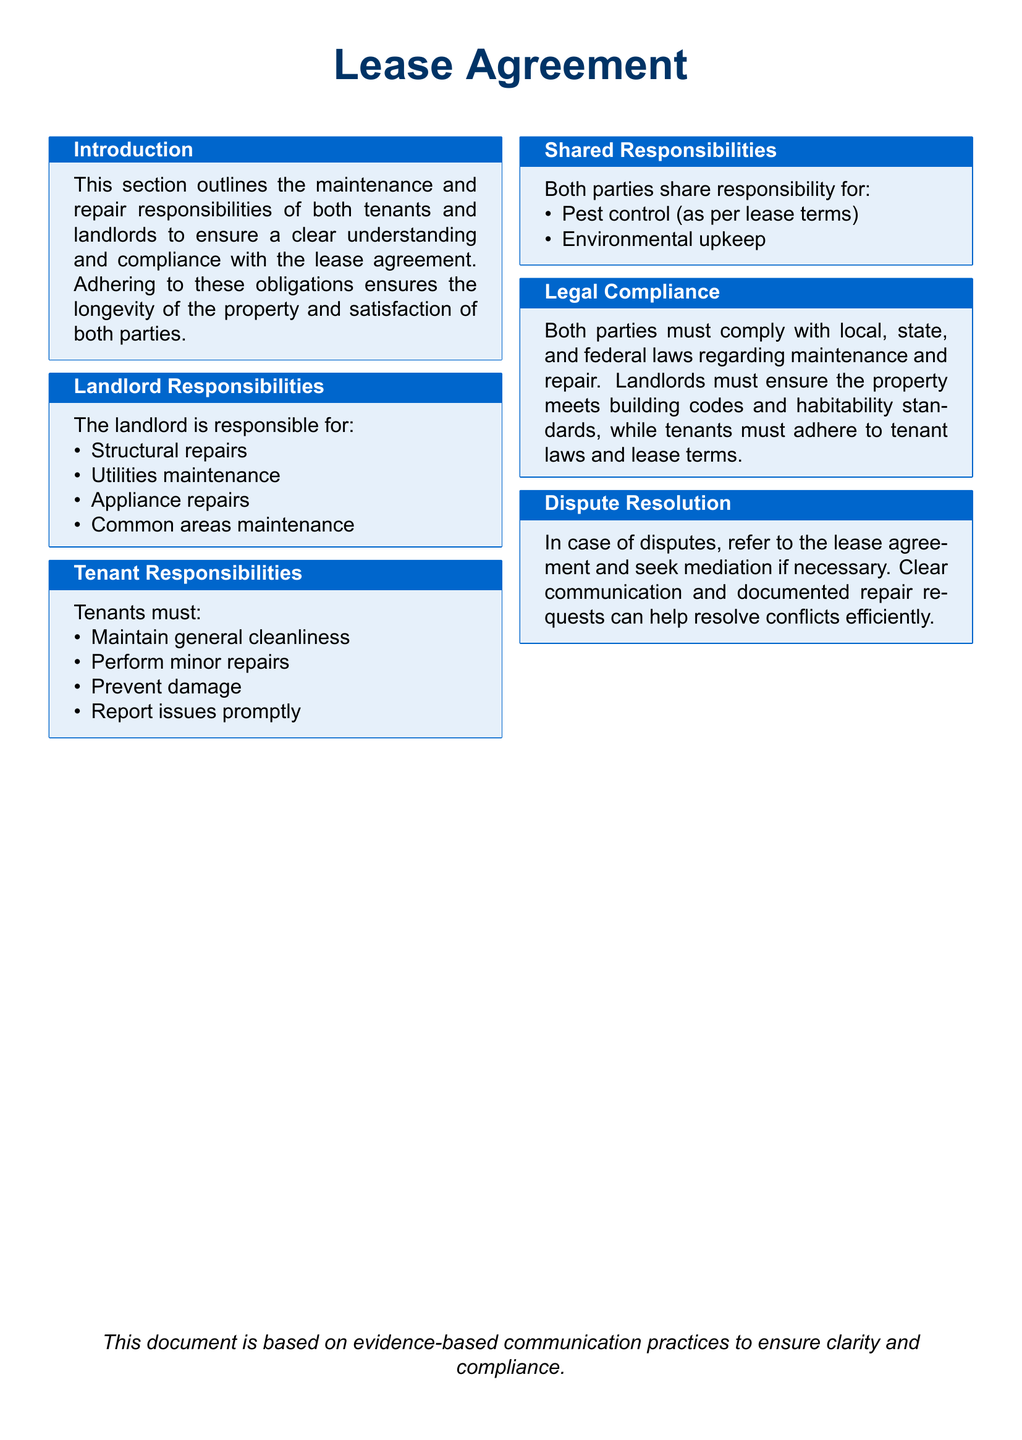What does the landlord maintain? The landlord maintains structural repairs, utilities maintenance, appliance repairs, and common areas according to the document.
Answer: Structural repairs, utilities maintenance, appliance repairs, common areas What must tenants do regarding cleanliness? The tenants are responsible for maintaining general cleanliness as outlined in the tenant responsibilities section of the document.
Answer: Maintain general cleanliness Who shares responsibility for pest control? The document states that pest control is a shared responsibility as per lease terms, implying that both parties have obligations.
Answer: Both parties What legal compliance must landlords ensure? The landlord must ensure the property meets building codes and habitability standards as mentioned in the legal compliance section.
Answer: Building codes, habitability standards What kind of repairs are tenants responsible for? Tenants are responsible for performing minor repairs according to the responsibilities outlined for tenants in the document.
Answer: Minor repairs What should tenants do when issues arise? The document specifies that tenants must report issues promptly when they arise.
Answer: Report issues promptly Who must adhere to tenant laws? Both parties must comply with local, state, and federal laws regarding maintenance and repair, specifically mentioning tenants in the document.
Answer: Tenants What type of repairs is the landlord not responsible for? Since the document lists landlord responsibilities, understanding what isn't included helps clarify expectations; however, specific exclusions aren't mentioned here.
Answer: Not specified 